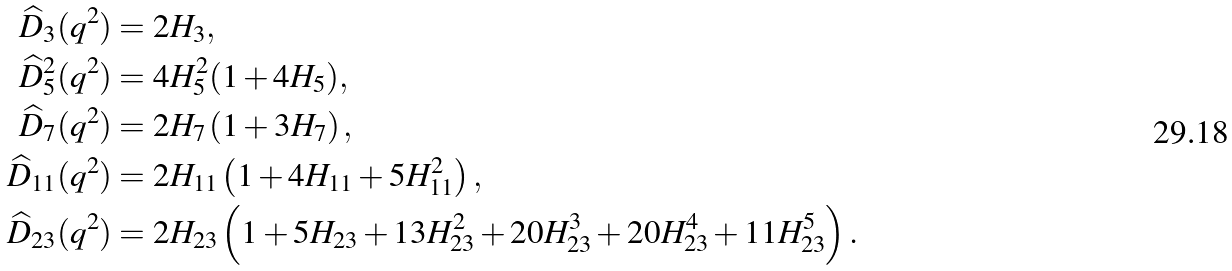<formula> <loc_0><loc_0><loc_500><loc_500>\widehat { D } _ { 3 } ( q ^ { 2 } ) & = 2 H _ { 3 } , \\ \widehat { D } _ { 5 } ^ { 2 } ( q ^ { 2 } ) & = 4 H _ { 5 } ^ { 2 } ( 1 + 4 H _ { 5 } ) , \\ \widehat { D } _ { 7 } ( q ^ { 2 } ) & = 2 H _ { 7 } \left ( 1 + 3 H _ { 7 } \right ) , \\ \widehat { D } _ { 1 1 } ( q ^ { 2 } ) & = 2 H _ { 1 1 } \left ( 1 + 4 H _ { 1 1 } + 5 H _ { 1 1 } ^ { 2 } \right ) , \\ \widehat { D } _ { 2 3 } ( q ^ { 2 } ) & = 2 H _ { 2 3 } \left ( 1 + 5 H _ { 2 3 } + 1 3 H _ { 2 3 } ^ { 2 } + 2 0 H _ { 2 3 } ^ { 3 } + 2 0 H _ { 2 3 } ^ { 4 } + 1 1 H _ { 2 3 } ^ { 5 } \right ) .</formula> 